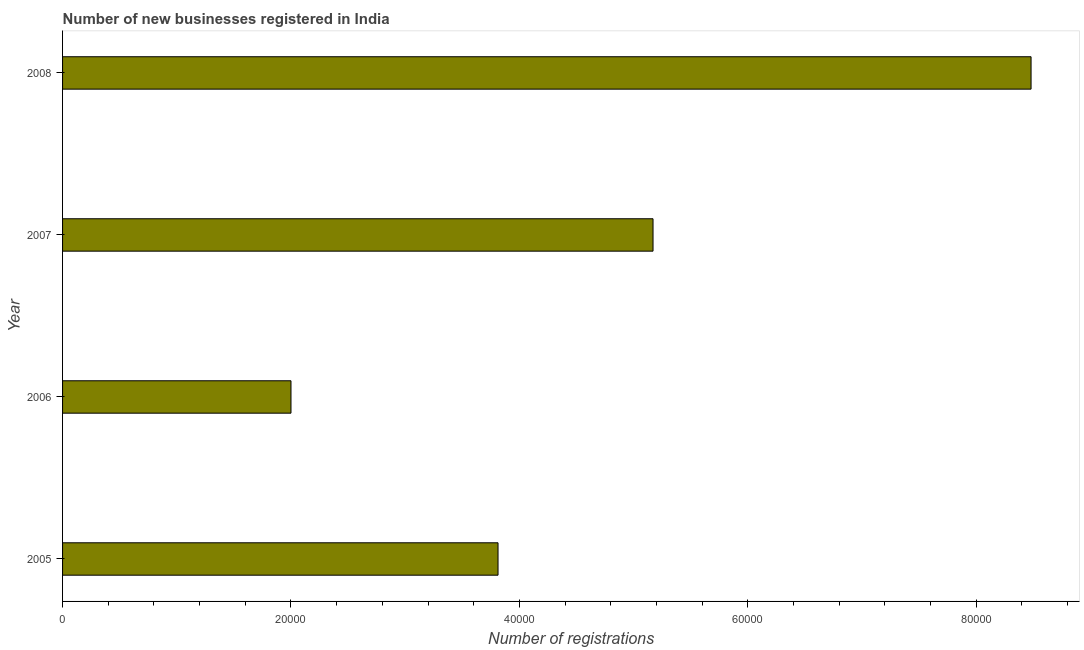Does the graph contain any zero values?
Ensure brevity in your answer.  No. Does the graph contain grids?
Make the answer very short. No. What is the title of the graph?
Your response must be concise. Number of new businesses registered in India. What is the label or title of the X-axis?
Provide a short and direct response. Number of registrations. What is the label or title of the Y-axis?
Make the answer very short. Year. Across all years, what is the maximum number of new business registrations?
Make the answer very short. 8.48e+04. Across all years, what is the minimum number of new business registrations?
Ensure brevity in your answer.  2.00e+04. In which year was the number of new business registrations maximum?
Your answer should be compact. 2008. What is the sum of the number of new business registrations?
Offer a very short reply. 1.95e+05. What is the difference between the number of new business registrations in 2007 and 2008?
Give a very brief answer. -3.31e+04. What is the average number of new business registrations per year?
Make the answer very short. 4.87e+04. What is the median number of new business registrations?
Make the answer very short. 4.49e+04. Do a majority of the years between 2008 and 2007 (inclusive) have number of new business registrations greater than 80000 ?
Keep it short and to the point. No. What is the ratio of the number of new business registrations in 2005 to that in 2008?
Give a very brief answer. 0.45. Is the number of new business registrations in 2005 less than that in 2007?
Offer a terse response. Yes. What is the difference between the highest and the second highest number of new business registrations?
Offer a very short reply. 3.31e+04. Is the sum of the number of new business registrations in 2006 and 2008 greater than the maximum number of new business registrations across all years?
Keep it short and to the point. Yes. What is the difference between the highest and the lowest number of new business registrations?
Your answer should be compact. 6.48e+04. In how many years, is the number of new business registrations greater than the average number of new business registrations taken over all years?
Give a very brief answer. 2. How many bars are there?
Keep it short and to the point. 4. Are all the bars in the graph horizontal?
Keep it short and to the point. Yes. Are the values on the major ticks of X-axis written in scientific E-notation?
Make the answer very short. No. What is the Number of registrations of 2005?
Give a very brief answer. 3.81e+04. What is the Number of registrations in 2007?
Your answer should be very brief. 5.17e+04. What is the Number of registrations of 2008?
Offer a very short reply. 8.48e+04. What is the difference between the Number of registrations in 2005 and 2006?
Offer a terse response. 1.81e+04. What is the difference between the Number of registrations in 2005 and 2007?
Keep it short and to the point. -1.36e+04. What is the difference between the Number of registrations in 2005 and 2008?
Keep it short and to the point. -4.67e+04. What is the difference between the Number of registrations in 2006 and 2007?
Your answer should be compact. -3.17e+04. What is the difference between the Number of registrations in 2006 and 2008?
Your answer should be very brief. -6.48e+04. What is the difference between the Number of registrations in 2007 and 2008?
Provide a short and direct response. -3.31e+04. What is the ratio of the Number of registrations in 2005 to that in 2006?
Offer a terse response. 1.91. What is the ratio of the Number of registrations in 2005 to that in 2007?
Your answer should be compact. 0.74. What is the ratio of the Number of registrations in 2005 to that in 2008?
Keep it short and to the point. 0.45. What is the ratio of the Number of registrations in 2006 to that in 2007?
Provide a short and direct response. 0.39. What is the ratio of the Number of registrations in 2006 to that in 2008?
Your answer should be very brief. 0.24. What is the ratio of the Number of registrations in 2007 to that in 2008?
Your response must be concise. 0.61. 